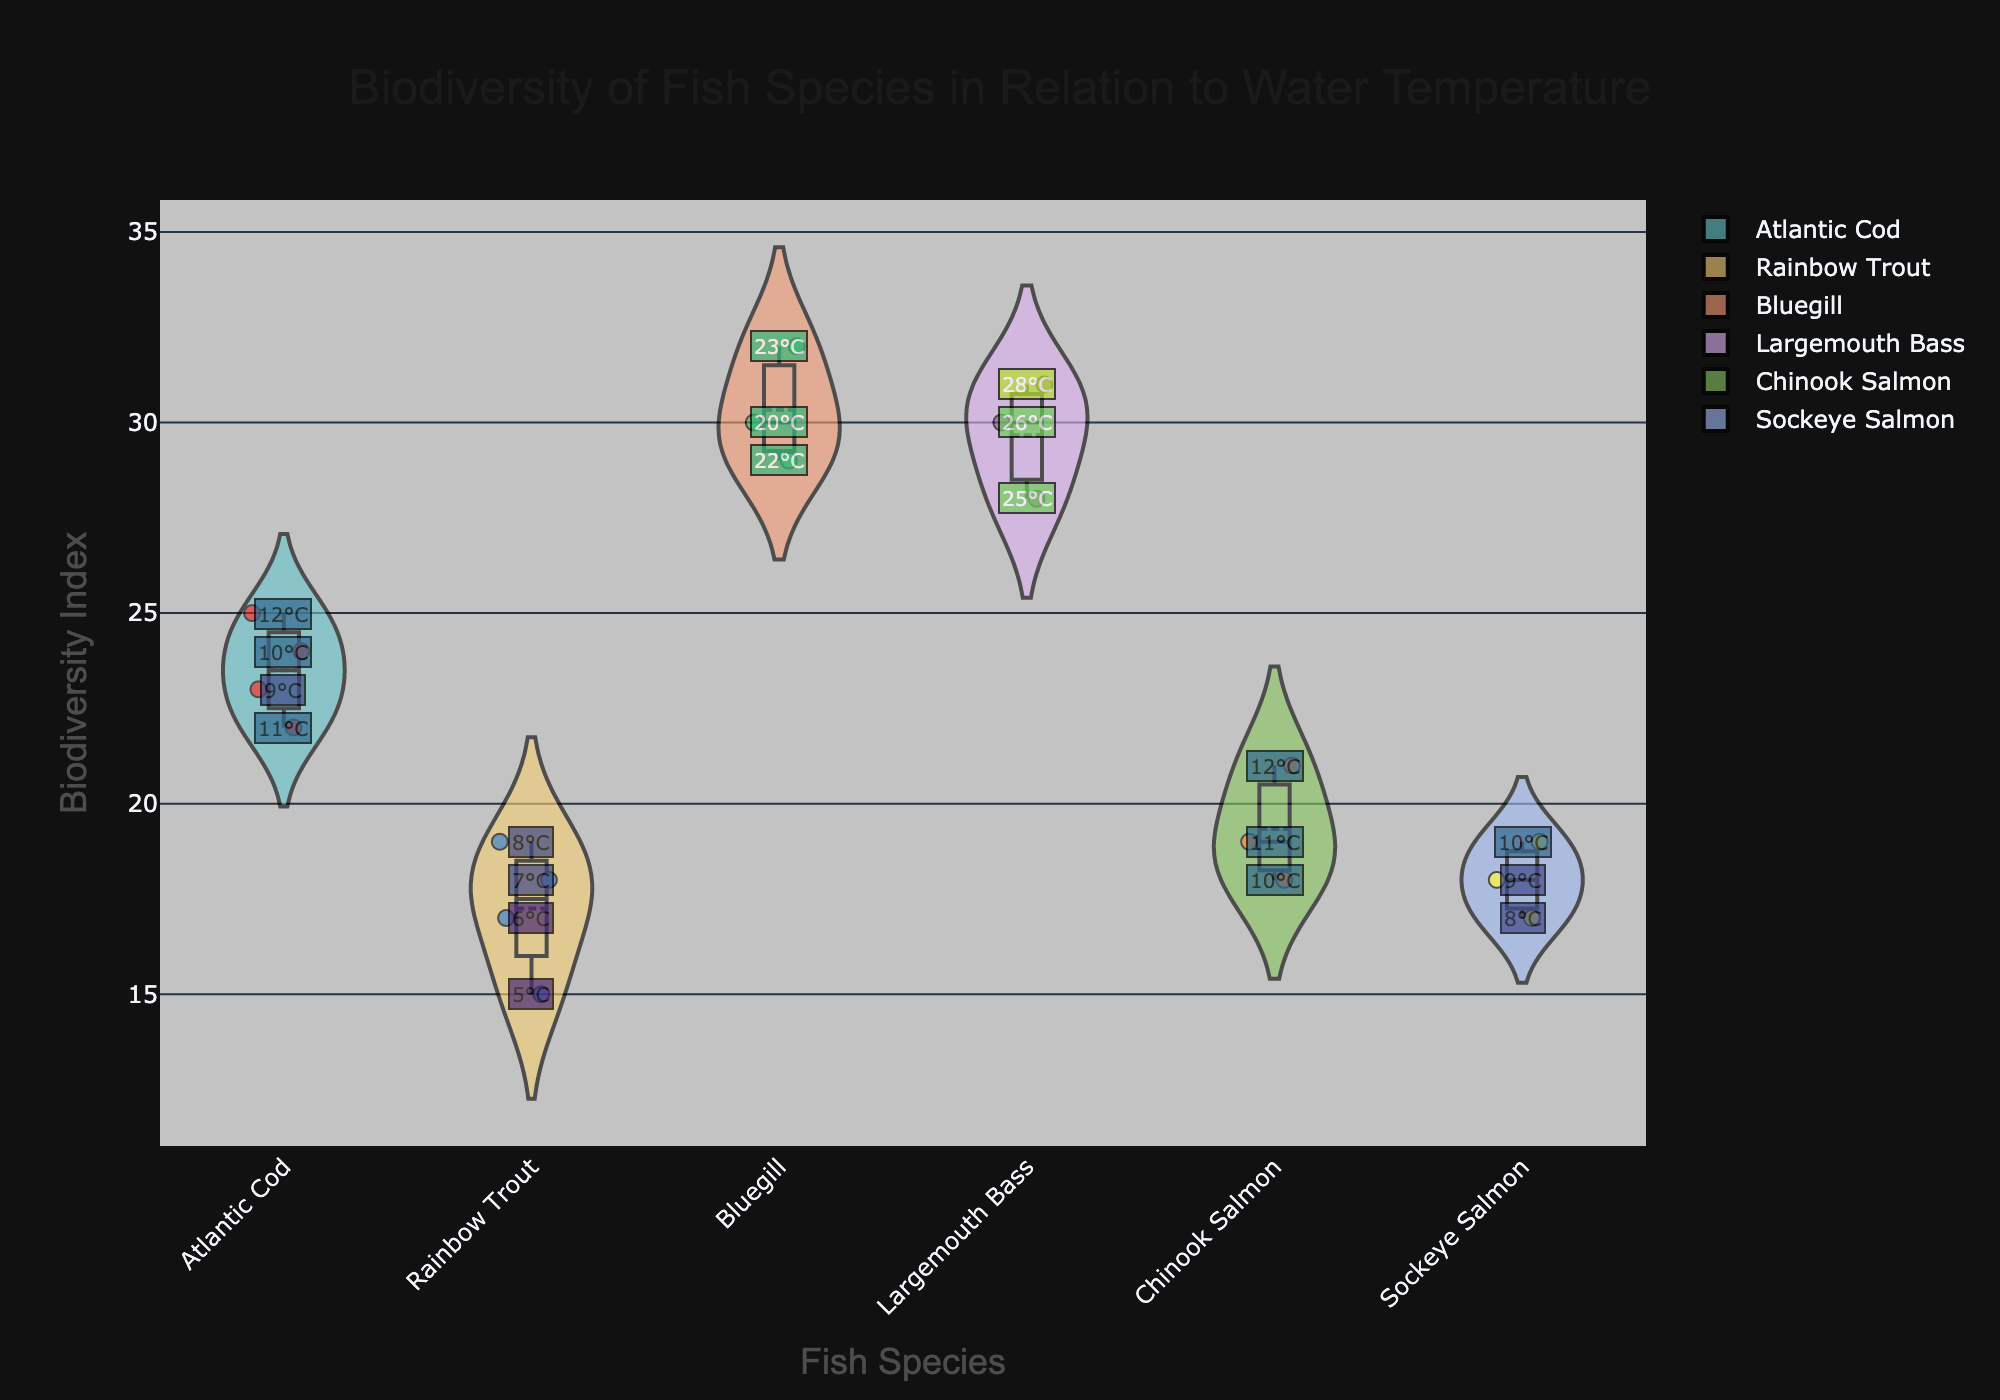What is the title of the figure? The title is located at the top of the figure and it clearly describes the subject of the data presented.
Answer: Biodiversity of Fish Species in Relation to Water Temperature Which fish species has the highest median biodiversity index? The figure shows box plots within the violin plots where the horizontal line inside the box represents the median. By reviewing these lines across all species, we can identify the species with the highest median.
Answer: Bluegill What is the average biodiversity index for Chinook Salmon and Sockeye Salmon combined? First, note the biodiversity index values for both species: Chinook Salmon (18, 19, 21) and Sockeye Salmon (17, 18, 19). Sum these values and then divide by the total number of data points. (18+19+21+17+18+19)/6 = 112/6.
Answer: 18.67 Compare the biodiversity indices at 10°C for Atlantic Cod and Rainbow Trout. Which one is higher? Check the annotations for 10°C, which are labeled within the points. Look at the biodiversity index at 10°C for Atlantic Cod (24) and Rainbow Trout (17).
Answer: Atlantic Cod Which fish species exhibits the widest spread in biodiversity index values? The spread of values can be evaluated by looking at the width of the violin plot, which visually represents the density and distribution of data. Identify the fish species with the widest spread.
Answer: Bluegill How many data points are there for Largemouth Bass? Count the individual points for the Largemouth Bass in the figure, noting the jittered points.
Answer: 3 Which fish species shows the least variability in biodiversity index? Least variability can be assessed by how narrow the violin plot appears. The narrowest plot with closely packed points would indicate minimal variability.
Answer: Atlantic Cod What is the highest biodiversity index recorded for Rainbow Trout? Identify the maximum point within the Rainbow Trout violin plot by looking at the positioning of the data points.
Answer: 19 Between Atlantic Cod and Sockeye Salmon, which species exhibits a higher average biodiversity index? Calculate the average biodiversity index for each species. For Atlantic Cod (23, 24, 22, 25), it's (23+24+22+25)/4 = 23.5. For Sockeye Salmon (17, 18, 19), it's (17+18+19)/3 = 18. Compare these averages.
Answer: Atlantic Cod Which fish species has data points at the highest water temperature? Look at the annotations on the data points to see which group contains the highest temperature among the displayed values.
Answer: Largemouth Bass 